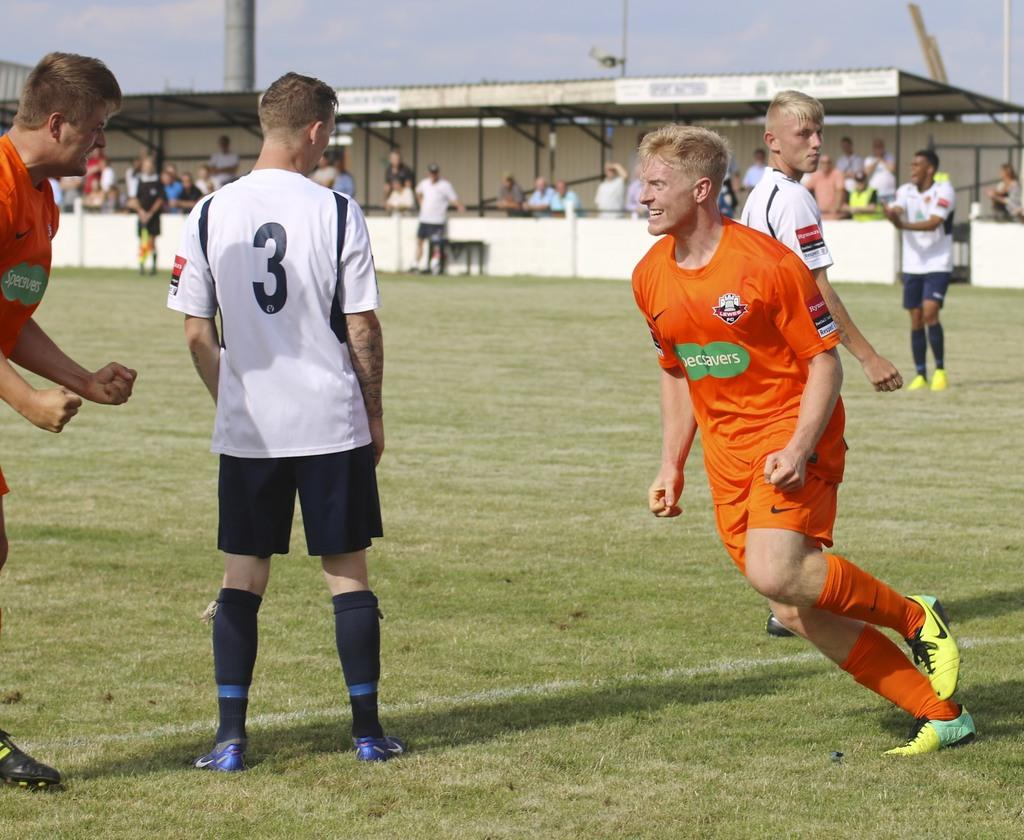<image>
Offer a succinct explanation of the picture presented. A player has an advert for specsavers on an orange shirt 